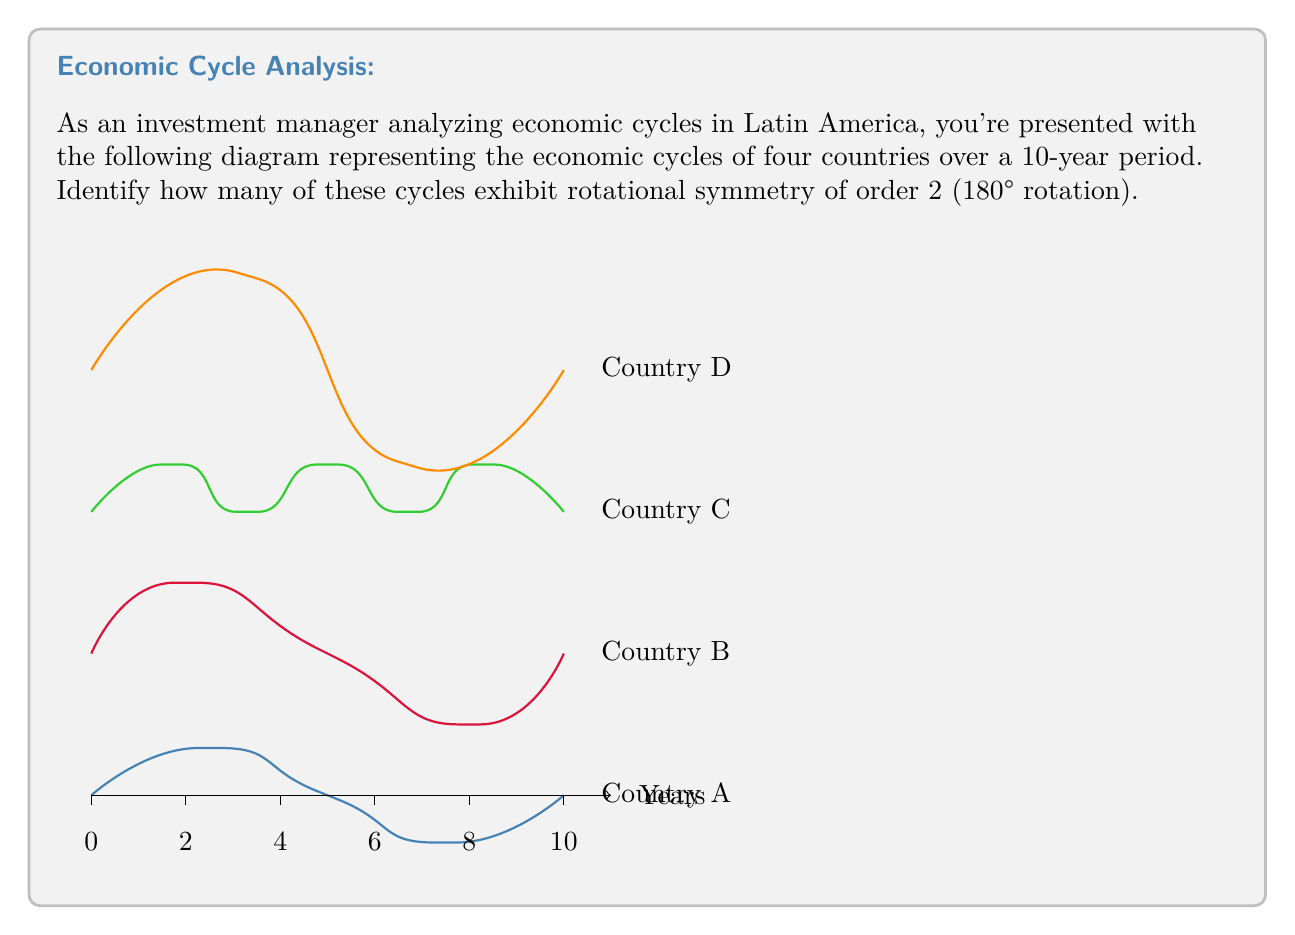Teach me how to tackle this problem. To determine which economic cycles exhibit rotational symmetry of order 2, we need to analyze each cycle individually:

1) Country A (Blue):
   The cycle completes two full periods in 10 years.
   If rotated 180°, it would align with itself.
   This cycle has rotational symmetry of order 2.

2) Country B (Red):
   The cycle does not complete a whole number of periods in 10 years.
   If rotated 180°, it would not align with itself.
   This cycle does not have rotational symmetry of order 2.

3) Country C (Green):
   The cycle completes three full periods in 10 years.
   If rotated 180°, it would align with itself.
   This cycle has rotational symmetry of order 2.

4) Country D (Orange):
   The cycle completes 1.5 periods in 10 years.
   If rotated 180°, it would align with itself.
   This cycle has rotational symmetry of order 2.

To have rotational symmetry of order 2, a cycle must look the same when rotated 180°. This occurs when the cycle completes a whole number of periods in half the given time frame (5 years in this case), or when it completes an odd number of half-periods in the full time frame.

Countries A, C, and D satisfy this condition, while Country B does not.

Therefore, 3 out of the 4 cycles exhibit rotational symmetry of order 2.
Answer: 3 